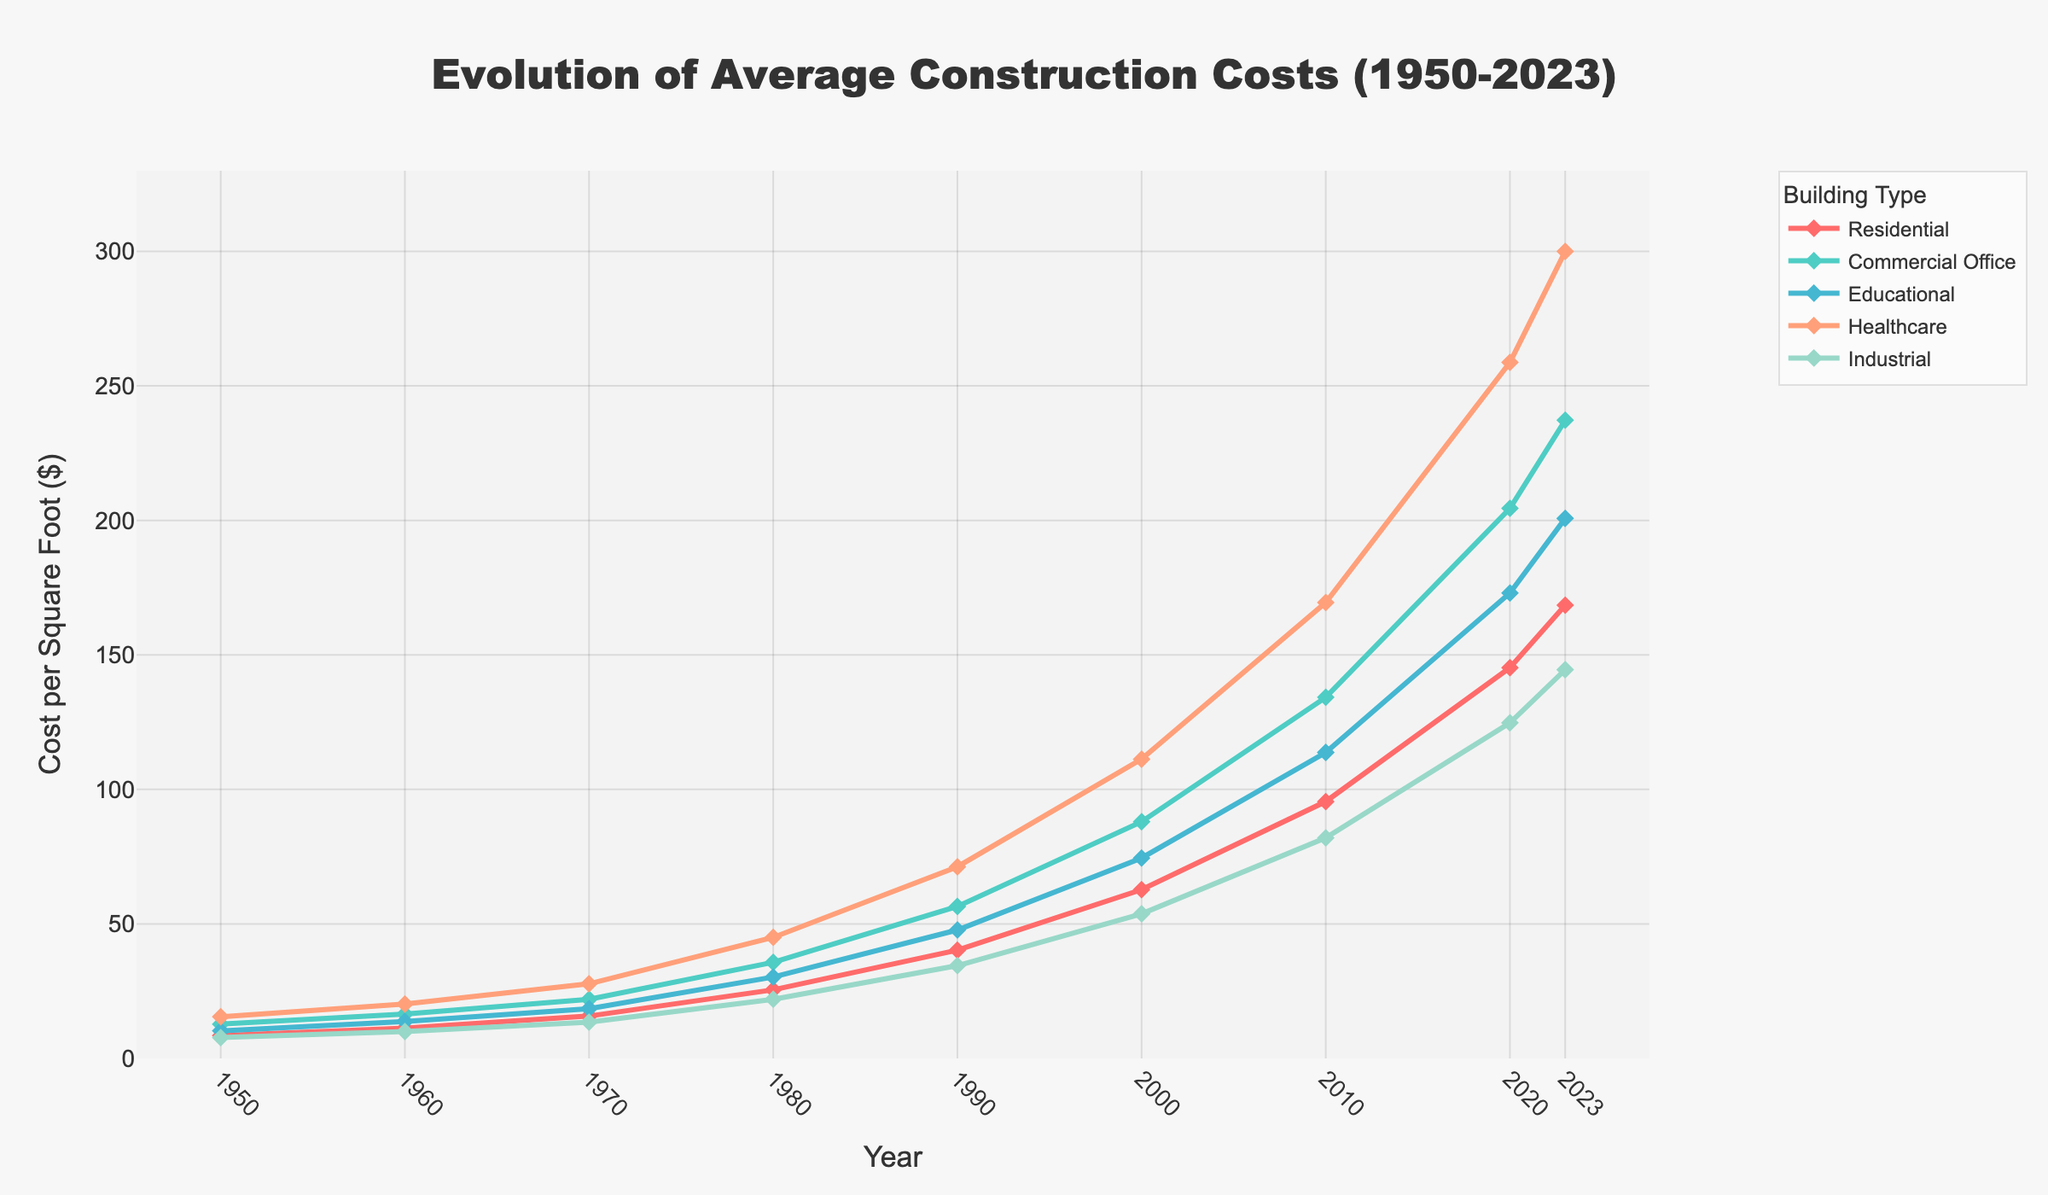Which building type had the highest construction cost per square foot in 2023? Look at the 2023 values for all building types. The highest value is 300.00 for Healthcare.
Answer: Healthcare How did the cost of Residential buildings change from 1950 to 2023? Subtract the cost in 1950 from the cost in 2023. 168.50 - 8.50 = 160.00
Answer: 160.00 Between 1980 and 2000, which building type saw the highest increase in cost per square foot? Calculate the difference for each building type between 1980 and 2000. The differences are: Residential (62.75 - 25.50 = 37.25), Commercial Office (88.00 - 35.75 = 52.25), Educational (74.50 - 30.25 = 44.25), Healthcare (111.25 - 45.00 = 66.25), Industrial (53.75 - 22.00 = 31.75). The highest increase is in Healthcare.
Answer: Healthcare What is the average cost per square foot for Educational buildings from 1950 to 2023? Sum the costs for Educational buildings and divide by the number of years. (10.25 + 13.75 + 18.50 + 30.25 + 47.75 + 74.50 + 113.75 + 173.00 + 200.75) / 9 = 87.17
Answer: 87.17 Which building type has the smallest increase in cost per square foot from 2010 to 2020? Calculate the difference for each building type between 2010 and 2020. The differences are: Residential (145.25 - 95.50 = 49.75), Commercial Office (204.50 - 134.25 = 70.25), Educational (173.00 - 113.75 = 59.25), Healthcare (258.75 - 169.50 = 89.25), Industrial (124.75 - 82.00 = 42.75). The smallest increase is in Industrial.
Answer: Industrial In what year did the Commercial Office building type exceed $50 per square foot? Look for the first year Commercial Office cost more than $50. This occurs in 1990.
Answer: 1990 Which building type had the steepest growth in cost per square foot from 1950 to 2023? Calculate the overall growth for each building type from 1950 to 2023. The differences are: Residential (168.50 - 8.50 = 160.00), Commercial Office (237.25 - 12.75 = 224.50), Educational (200.75 - 10.25 = 190.50), Healthcare (300.00 - 15.50 = 284.50), Industrial (144.50 - 7.75 = 136.75). The steepest growth is in Healthcare.
Answer: Healthcare Which building types' costs have crossed $100 per square foot by 2010? Check the costs of each building type in 2010: Residential (95.50), Commercial Office (134.25), Educational (113.75), Healthcare (169.50), Industrial (82.00). Those crossing $100 are Commercial Office, Educational, and Healthcare.
Answer: Commercial Office, Educational, Healthcare 